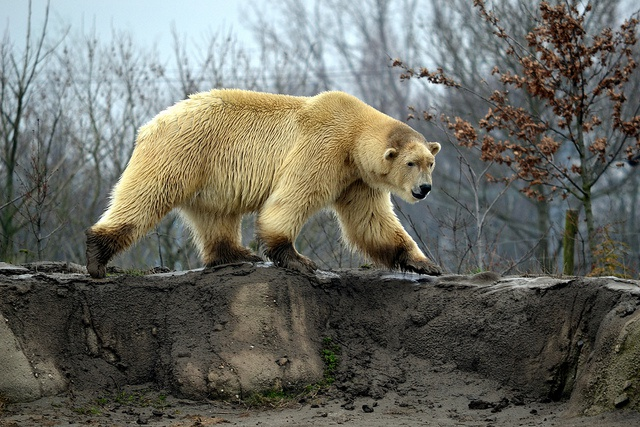Describe the objects in this image and their specific colors. I can see a bear in lightblue, tan, khaki, olive, and black tones in this image. 